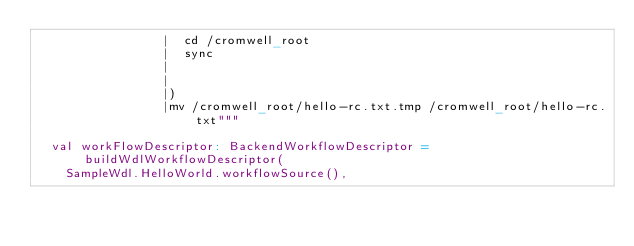<code> <loc_0><loc_0><loc_500><loc_500><_Scala_>                 |  cd /cromwell_root
                 |  sync
                 |
                 |
                 |)
                 |mv /cromwell_root/hello-rc.txt.tmp /cromwell_root/hello-rc.txt"""

  val workFlowDescriptor: BackendWorkflowDescriptor = buildWdlWorkflowDescriptor(
    SampleWdl.HelloWorld.workflowSource(),</code> 